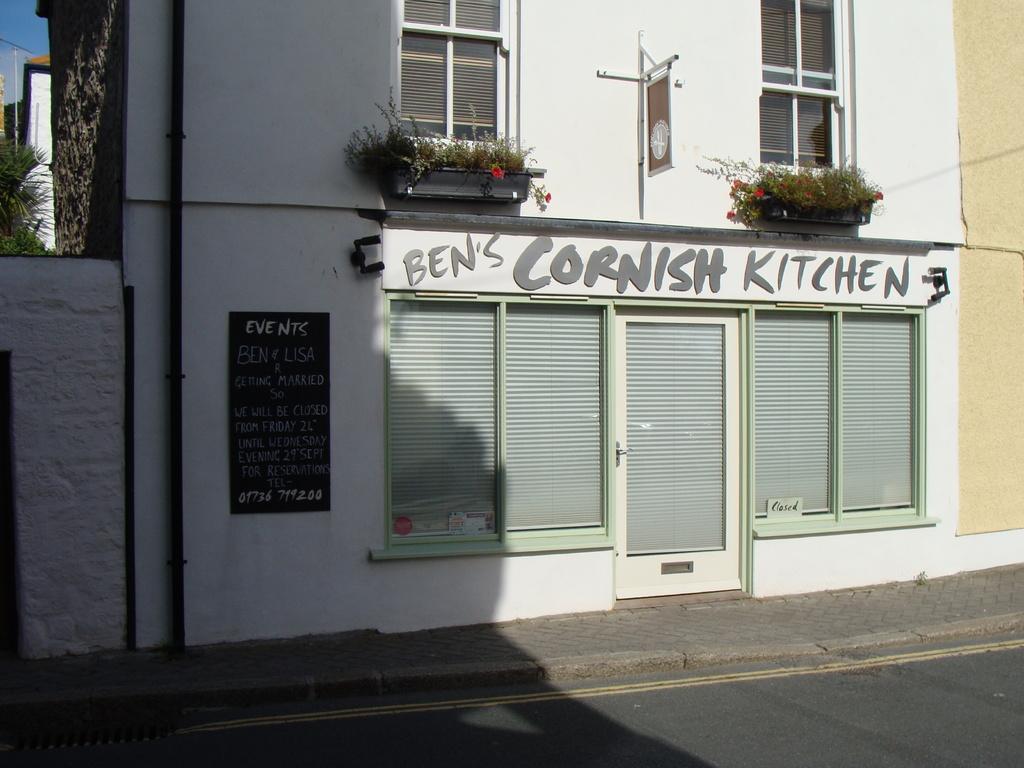Please provide a concise description of this image. In this image we can see houses, windows, a door, there are boards with text on it, there are plants, a tree, also we can see the sky. 